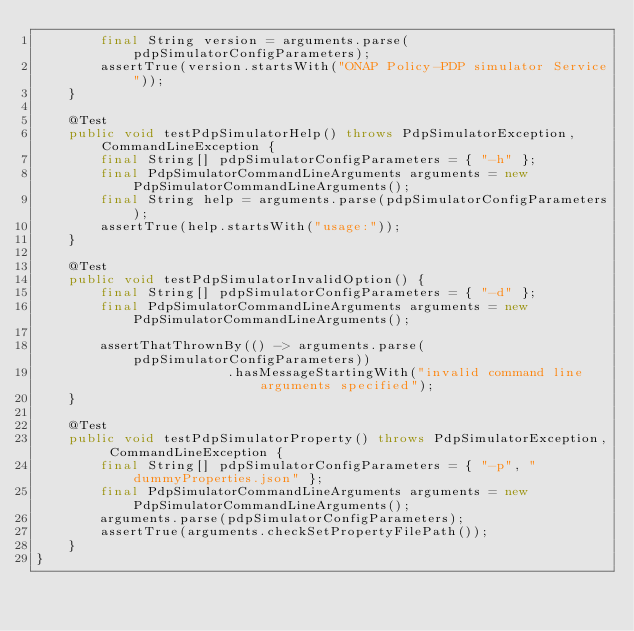<code> <loc_0><loc_0><loc_500><loc_500><_Java_>        final String version = arguments.parse(pdpSimulatorConfigParameters);
        assertTrue(version.startsWith("ONAP Policy-PDP simulator Service"));
    }

    @Test
    public void testPdpSimulatorHelp() throws PdpSimulatorException, CommandLineException {
        final String[] pdpSimulatorConfigParameters = { "-h" };
        final PdpSimulatorCommandLineArguments arguments = new PdpSimulatorCommandLineArguments();
        final String help = arguments.parse(pdpSimulatorConfigParameters);
        assertTrue(help.startsWith("usage:"));
    }

    @Test
    public void testPdpSimulatorInvalidOption() {
        final String[] pdpSimulatorConfigParameters = { "-d" };
        final PdpSimulatorCommandLineArguments arguments = new PdpSimulatorCommandLineArguments();

        assertThatThrownBy(() -> arguments.parse(pdpSimulatorConfigParameters))
                        .hasMessageStartingWith("invalid command line arguments specified");
    }

    @Test
    public void testPdpSimulatorProperty() throws PdpSimulatorException, CommandLineException {
        final String[] pdpSimulatorConfigParameters = { "-p", "dummyProperties.json" };
        final PdpSimulatorCommandLineArguments arguments = new PdpSimulatorCommandLineArguments();
        arguments.parse(pdpSimulatorConfigParameters);
        assertTrue(arguments.checkSetPropertyFilePath());
    }
}
</code> 